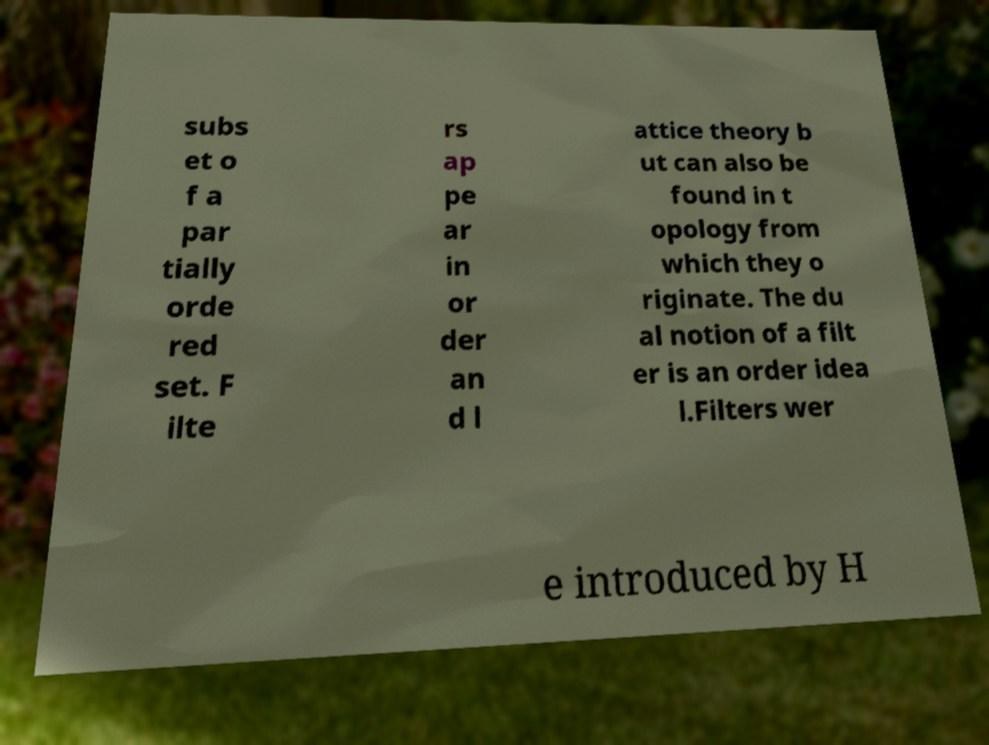Please identify and transcribe the text found in this image. subs et o f a par tially orde red set. F ilte rs ap pe ar in or der an d l attice theory b ut can also be found in t opology from which they o riginate. The du al notion of a filt er is an order idea l.Filters wer e introduced by H 